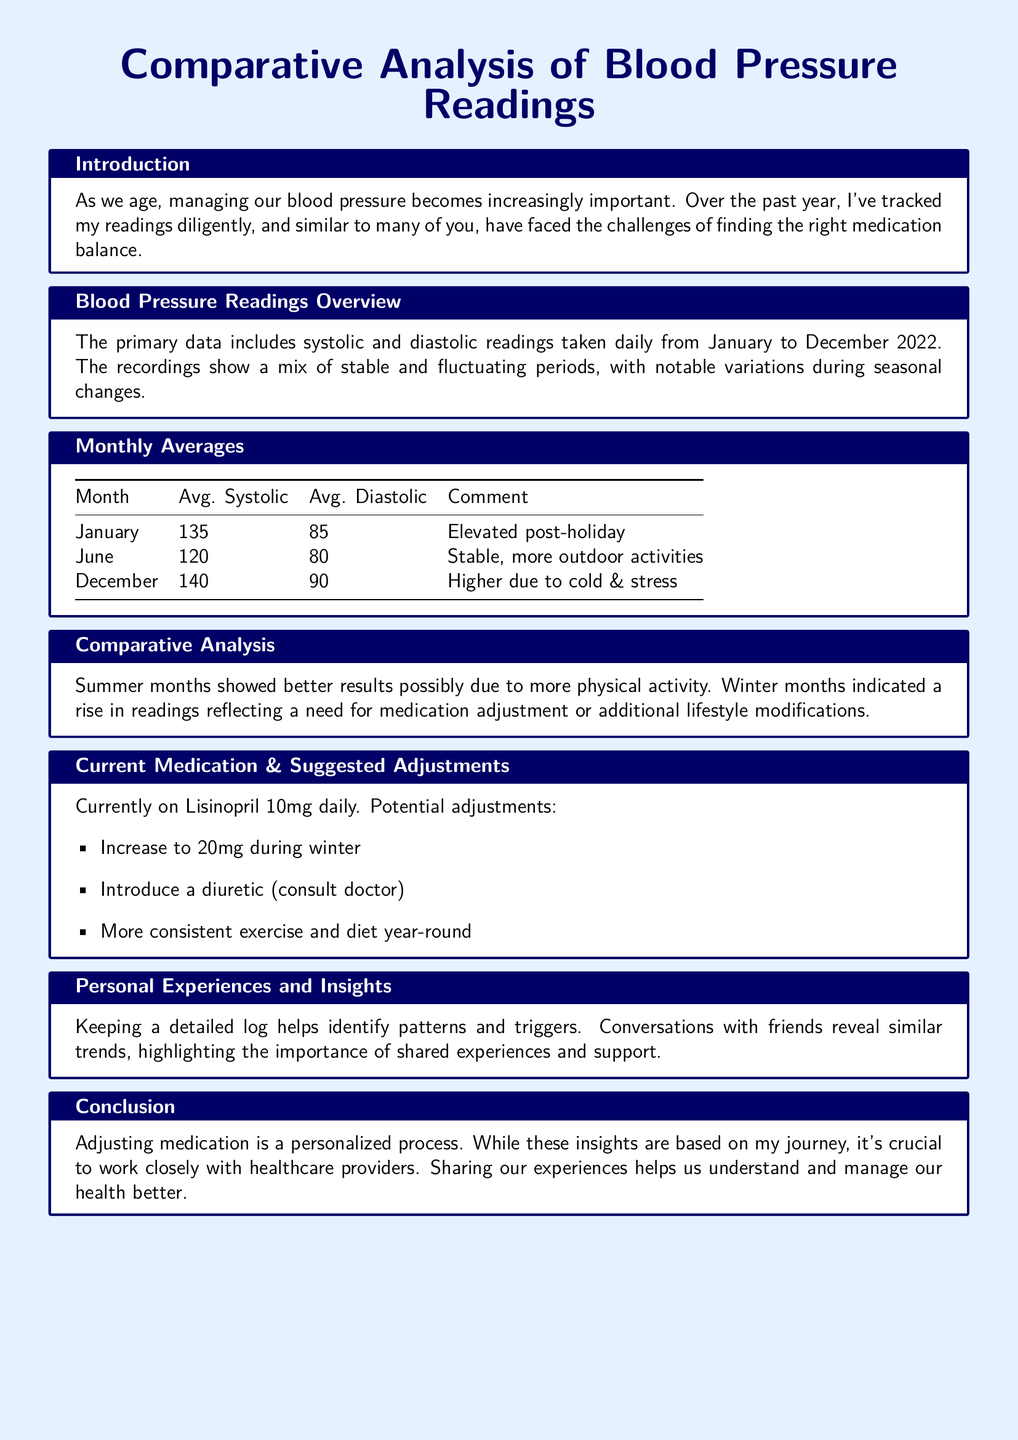What is the average systolic reading in January? The average systolic reading in January is stated as 135 in the document.
Answer: 135 What is the average diastolic reading in December? The document lists the average diastolic reading for December as 90.
Answer: 90 What medication is currently being taken? The document identifies the current medication as Lisinopril.
Answer: Lisinopril What lifestyle factor contributed to better readings in summer? The document suggests that more physical activity contributed to better readings in summer.
Answer: Physical activity What specific suggestion is made for winter medication adjustment? The document recommends increasing the dosage to 20mg during winter months.
Answer: Increase to 20mg Which month recorded the lowest average diastolic pressure? Analyzing the data, June is recorded with an average diastolic pressure of 80, the lowest among the listed months.
Answer: June How are the trends in blood pressure readings during seasonal changes described? The document mentions that winter months indicated a rise in readings.
Answer: Rise in readings What is the purpose of keeping a detailed log according to the document? The document states that keeping a detailed log helps identify patterns and triggers.
Answer: Identify patterns What role do conversations with friends play in managing health? The document mentions that conversations with friends reveal similar trends.
Answer: Reveal similar trends 